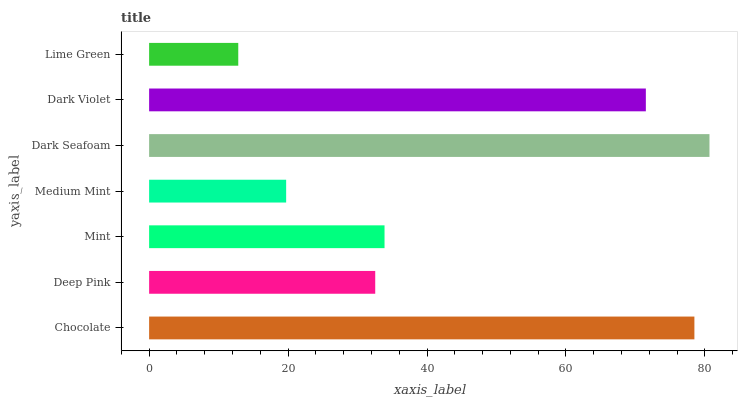Is Lime Green the minimum?
Answer yes or no. Yes. Is Dark Seafoam the maximum?
Answer yes or no. Yes. Is Deep Pink the minimum?
Answer yes or no. No. Is Deep Pink the maximum?
Answer yes or no. No. Is Chocolate greater than Deep Pink?
Answer yes or no. Yes. Is Deep Pink less than Chocolate?
Answer yes or no. Yes. Is Deep Pink greater than Chocolate?
Answer yes or no. No. Is Chocolate less than Deep Pink?
Answer yes or no. No. Is Mint the high median?
Answer yes or no. Yes. Is Mint the low median?
Answer yes or no. Yes. Is Dark Violet the high median?
Answer yes or no. No. Is Lime Green the low median?
Answer yes or no. No. 